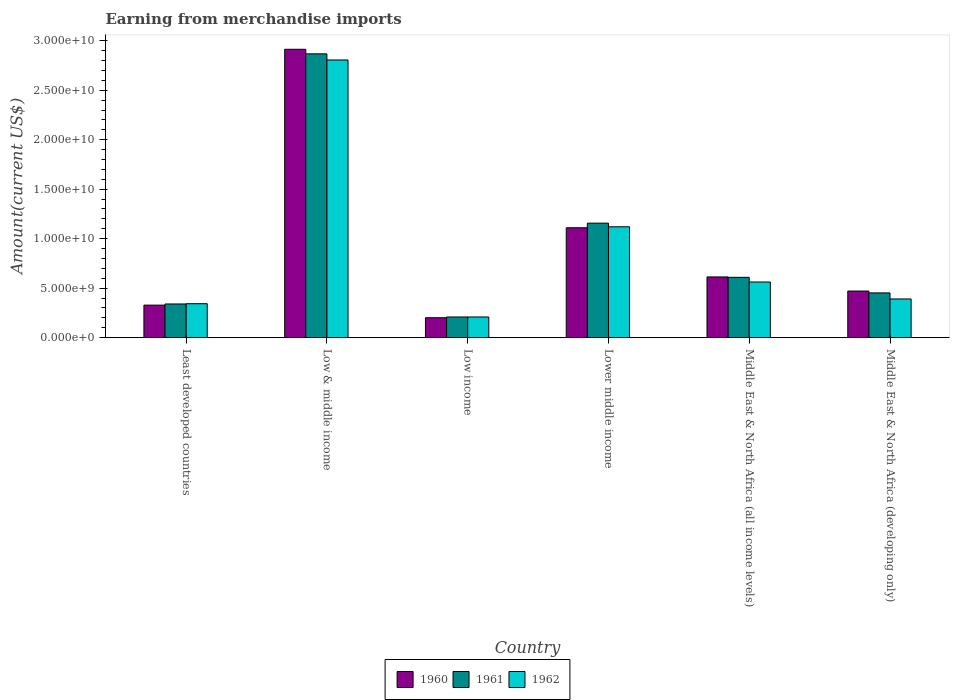How many different coloured bars are there?
Provide a short and direct response. 3. How many groups of bars are there?
Provide a short and direct response. 6. Are the number of bars per tick equal to the number of legend labels?
Provide a short and direct response. Yes. Are the number of bars on each tick of the X-axis equal?
Your answer should be very brief. Yes. How many bars are there on the 5th tick from the left?
Provide a short and direct response. 3. How many bars are there on the 1st tick from the right?
Provide a short and direct response. 3. What is the label of the 2nd group of bars from the left?
Give a very brief answer. Low & middle income. What is the amount earned from merchandise imports in 1961 in Middle East & North Africa (developing only)?
Give a very brief answer. 4.52e+09. Across all countries, what is the maximum amount earned from merchandise imports in 1960?
Your answer should be very brief. 2.91e+1. Across all countries, what is the minimum amount earned from merchandise imports in 1962?
Make the answer very short. 2.09e+09. In which country was the amount earned from merchandise imports in 1962 maximum?
Provide a succinct answer. Low & middle income. What is the total amount earned from merchandise imports in 1962 in the graph?
Provide a short and direct response. 5.43e+1. What is the difference between the amount earned from merchandise imports in 1960 in Low & middle income and that in Lower middle income?
Ensure brevity in your answer.  1.80e+1. What is the difference between the amount earned from merchandise imports in 1961 in Least developed countries and the amount earned from merchandise imports in 1962 in Low & middle income?
Provide a succinct answer. -2.47e+1. What is the average amount earned from merchandise imports in 1960 per country?
Your answer should be compact. 9.40e+09. What is the difference between the amount earned from merchandise imports of/in 1961 and amount earned from merchandise imports of/in 1962 in Low & middle income?
Your response must be concise. 6.18e+08. What is the ratio of the amount earned from merchandise imports in 1960 in Least developed countries to that in Middle East & North Africa (developing only)?
Offer a terse response. 0.7. What is the difference between the highest and the second highest amount earned from merchandise imports in 1961?
Keep it short and to the point. 5.47e+09. What is the difference between the highest and the lowest amount earned from merchandise imports in 1960?
Make the answer very short. 2.71e+1. In how many countries, is the amount earned from merchandise imports in 1961 greater than the average amount earned from merchandise imports in 1961 taken over all countries?
Your answer should be compact. 2. Is the sum of the amount earned from merchandise imports in 1960 in Low income and Middle East & North Africa (developing only) greater than the maximum amount earned from merchandise imports in 1961 across all countries?
Make the answer very short. No. What does the 1st bar from the right in Middle East & North Africa (all income levels) represents?
Keep it short and to the point. 1962. Is it the case that in every country, the sum of the amount earned from merchandise imports in 1961 and amount earned from merchandise imports in 1962 is greater than the amount earned from merchandise imports in 1960?
Offer a terse response. Yes. Are all the bars in the graph horizontal?
Offer a very short reply. No. What is the difference between two consecutive major ticks on the Y-axis?
Your answer should be compact. 5.00e+09. Are the values on the major ticks of Y-axis written in scientific E-notation?
Make the answer very short. Yes. Does the graph contain any zero values?
Offer a very short reply. No. Does the graph contain grids?
Offer a very short reply. No. How are the legend labels stacked?
Your response must be concise. Horizontal. What is the title of the graph?
Offer a terse response. Earning from merchandise imports. What is the label or title of the X-axis?
Make the answer very short. Country. What is the label or title of the Y-axis?
Provide a short and direct response. Amount(current US$). What is the Amount(current US$) of 1960 in Least developed countries?
Make the answer very short. 3.29e+09. What is the Amount(current US$) in 1961 in Least developed countries?
Offer a terse response. 3.40e+09. What is the Amount(current US$) in 1962 in Least developed countries?
Keep it short and to the point. 3.43e+09. What is the Amount(current US$) of 1960 in Low & middle income?
Keep it short and to the point. 2.91e+1. What is the Amount(current US$) in 1961 in Low & middle income?
Ensure brevity in your answer.  2.87e+1. What is the Amount(current US$) of 1962 in Low & middle income?
Ensure brevity in your answer.  2.81e+1. What is the Amount(current US$) of 1960 in Low income?
Offer a terse response. 2.01e+09. What is the Amount(current US$) of 1961 in Low income?
Offer a very short reply. 2.09e+09. What is the Amount(current US$) in 1962 in Low income?
Your response must be concise. 2.09e+09. What is the Amount(current US$) of 1960 in Lower middle income?
Your answer should be very brief. 1.11e+1. What is the Amount(current US$) of 1961 in Lower middle income?
Give a very brief answer. 1.16e+1. What is the Amount(current US$) of 1962 in Lower middle income?
Your answer should be very brief. 1.12e+1. What is the Amount(current US$) of 1960 in Middle East & North Africa (all income levels)?
Your response must be concise. 6.14e+09. What is the Amount(current US$) in 1961 in Middle East & North Africa (all income levels)?
Offer a very short reply. 6.10e+09. What is the Amount(current US$) in 1962 in Middle East & North Africa (all income levels)?
Offer a very short reply. 5.62e+09. What is the Amount(current US$) of 1960 in Middle East & North Africa (developing only)?
Your answer should be compact. 4.71e+09. What is the Amount(current US$) in 1961 in Middle East & North Africa (developing only)?
Provide a short and direct response. 4.52e+09. What is the Amount(current US$) in 1962 in Middle East & North Africa (developing only)?
Ensure brevity in your answer.  3.91e+09. Across all countries, what is the maximum Amount(current US$) of 1960?
Your response must be concise. 2.91e+1. Across all countries, what is the maximum Amount(current US$) of 1961?
Your answer should be compact. 2.87e+1. Across all countries, what is the maximum Amount(current US$) of 1962?
Offer a terse response. 2.81e+1. Across all countries, what is the minimum Amount(current US$) of 1960?
Your answer should be very brief. 2.01e+09. Across all countries, what is the minimum Amount(current US$) in 1961?
Your answer should be very brief. 2.09e+09. Across all countries, what is the minimum Amount(current US$) of 1962?
Your answer should be very brief. 2.09e+09. What is the total Amount(current US$) of 1960 in the graph?
Ensure brevity in your answer.  5.64e+1. What is the total Amount(current US$) of 1961 in the graph?
Provide a succinct answer. 5.64e+1. What is the total Amount(current US$) of 1962 in the graph?
Ensure brevity in your answer.  5.43e+1. What is the difference between the Amount(current US$) in 1960 in Least developed countries and that in Low & middle income?
Provide a short and direct response. -2.58e+1. What is the difference between the Amount(current US$) in 1961 in Least developed countries and that in Low & middle income?
Provide a short and direct response. -2.53e+1. What is the difference between the Amount(current US$) of 1962 in Least developed countries and that in Low & middle income?
Your answer should be compact. -2.46e+1. What is the difference between the Amount(current US$) in 1960 in Least developed countries and that in Low income?
Ensure brevity in your answer.  1.27e+09. What is the difference between the Amount(current US$) in 1961 in Least developed countries and that in Low income?
Keep it short and to the point. 1.31e+09. What is the difference between the Amount(current US$) of 1962 in Least developed countries and that in Low income?
Provide a succinct answer. 1.34e+09. What is the difference between the Amount(current US$) of 1960 in Least developed countries and that in Lower middle income?
Your answer should be very brief. -7.81e+09. What is the difference between the Amount(current US$) of 1961 in Least developed countries and that in Lower middle income?
Your answer should be compact. -8.17e+09. What is the difference between the Amount(current US$) of 1962 in Least developed countries and that in Lower middle income?
Your answer should be very brief. -7.77e+09. What is the difference between the Amount(current US$) in 1960 in Least developed countries and that in Middle East & North Africa (all income levels)?
Keep it short and to the point. -2.85e+09. What is the difference between the Amount(current US$) in 1961 in Least developed countries and that in Middle East & North Africa (all income levels)?
Offer a terse response. -2.69e+09. What is the difference between the Amount(current US$) in 1962 in Least developed countries and that in Middle East & North Africa (all income levels)?
Your answer should be compact. -2.19e+09. What is the difference between the Amount(current US$) of 1960 in Least developed countries and that in Middle East & North Africa (developing only)?
Give a very brief answer. -1.42e+09. What is the difference between the Amount(current US$) of 1961 in Least developed countries and that in Middle East & North Africa (developing only)?
Give a very brief answer. -1.12e+09. What is the difference between the Amount(current US$) of 1962 in Least developed countries and that in Middle East & North Africa (developing only)?
Offer a terse response. -4.79e+08. What is the difference between the Amount(current US$) in 1960 in Low & middle income and that in Low income?
Keep it short and to the point. 2.71e+1. What is the difference between the Amount(current US$) of 1961 in Low & middle income and that in Low income?
Provide a short and direct response. 2.66e+1. What is the difference between the Amount(current US$) in 1962 in Low & middle income and that in Low income?
Provide a short and direct response. 2.60e+1. What is the difference between the Amount(current US$) in 1960 in Low & middle income and that in Lower middle income?
Your answer should be compact. 1.80e+1. What is the difference between the Amount(current US$) in 1961 in Low & middle income and that in Lower middle income?
Offer a very short reply. 1.71e+1. What is the difference between the Amount(current US$) of 1962 in Low & middle income and that in Lower middle income?
Offer a very short reply. 1.69e+1. What is the difference between the Amount(current US$) of 1960 in Low & middle income and that in Middle East & North Africa (all income levels)?
Provide a short and direct response. 2.30e+1. What is the difference between the Amount(current US$) of 1961 in Low & middle income and that in Middle East & North Africa (all income levels)?
Provide a succinct answer. 2.26e+1. What is the difference between the Amount(current US$) of 1962 in Low & middle income and that in Middle East & North Africa (all income levels)?
Provide a succinct answer. 2.24e+1. What is the difference between the Amount(current US$) in 1960 in Low & middle income and that in Middle East & North Africa (developing only)?
Your response must be concise. 2.44e+1. What is the difference between the Amount(current US$) in 1961 in Low & middle income and that in Middle East & North Africa (developing only)?
Offer a terse response. 2.42e+1. What is the difference between the Amount(current US$) of 1962 in Low & middle income and that in Middle East & North Africa (developing only)?
Your answer should be very brief. 2.41e+1. What is the difference between the Amount(current US$) of 1960 in Low income and that in Lower middle income?
Your response must be concise. -9.09e+09. What is the difference between the Amount(current US$) in 1961 in Low income and that in Lower middle income?
Keep it short and to the point. -9.48e+09. What is the difference between the Amount(current US$) in 1962 in Low income and that in Lower middle income?
Provide a succinct answer. -9.11e+09. What is the difference between the Amount(current US$) of 1960 in Low income and that in Middle East & North Africa (all income levels)?
Keep it short and to the point. -4.12e+09. What is the difference between the Amount(current US$) in 1961 in Low income and that in Middle East & North Africa (all income levels)?
Offer a terse response. -4.01e+09. What is the difference between the Amount(current US$) of 1962 in Low income and that in Middle East & North Africa (all income levels)?
Make the answer very short. -3.53e+09. What is the difference between the Amount(current US$) of 1960 in Low income and that in Middle East & North Africa (developing only)?
Your response must be concise. -2.70e+09. What is the difference between the Amount(current US$) in 1961 in Low income and that in Middle East & North Africa (developing only)?
Offer a very short reply. -2.43e+09. What is the difference between the Amount(current US$) in 1962 in Low income and that in Middle East & North Africa (developing only)?
Offer a very short reply. -1.82e+09. What is the difference between the Amount(current US$) in 1960 in Lower middle income and that in Middle East & North Africa (all income levels)?
Your answer should be very brief. 4.97e+09. What is the difference between the Amount(current US$) of 1961 in Lower middle income and that in Middle East & North Africa (all income levels)?
Ensure brevity in your answer.  5.47e+09. What is the difference between the Amount(current US$) of 1962 in Lower middle income and that in Middle East & North Africa (all income levels)?
Provide a succinct answer. 5.58e+09. What is the difference between the Amount(current US$) in 1960 in Lower middle income and that in Middle East & North Africa (developing only)?
Your answer should be compact. 6.39e+09. What is the difference between the Amount(current US$) in 1961 in Lower middle income and that in Middle East & North Africa (developing only)?
Offer a very short reply. 7.05e+09. What is the difference between the Amount(current US$) in 1962 in Lower middle income and that in Middle East & North Africa (developing only)?
Your answer should be very brief. 7.29e+09. What is the difference between the Amount(current US$) of 1960 in Middle East & North Africa (all income levels) and that in Middle East & North Africa (developing only)?
Keep it short and to the point. 1.43e+09. What is the difference between the Amount(current US$) in 1961 in Middle East & North Africa (all income levels) and that in Middle East & North Africa (developing only)?
Your response must be concise. 1.57e+09. What is the difference between the Amount(current US$) in 1962 in Middle East & North Africa (all income levels) and that in Middle East & North Africa (developing only)?
Keep it short and to the point. 1.71e+09. What is the difference between the Amount(current US$) of 1960 in Least developed countries and the Amount(current US$) of 1961 in Low & middle income?
Your answer should be very brief. -2.54e+1. What is the difference between the Amount(current US$) of 1960 in Least developed countries and the Amount(current US$) of 1962 in Low & middle income?
Your response must be concise. -2.48e+1. What is the difference between the Amount(current US$) in 1961 in Least developed countries and the Amount(current US$) in 1962 in Low & middle income?
Offer a very short reply. -2.47e+1. What is the difference between the Amount(current US$) in 1960 in Least developed countries and the Amount(current US$) in 1961 in Low income?
Keep it short and to the point. 1.20e+09. What is the difference between the Amount(current US$) in 1960 in Least developed countries and the Amount(current US$) in 1962 in Low income?
Give a very brief answer. 1.20e+09. What is the difference between the Amount(current US$) of 1961 in Least developed countries and the Amount(current US$) of 1962 in Low income?
Offer a very short reply. 1.31e+09. What is the difference between the Amount(current US$) in 1960 in Least developed countries and the Amount(current US$) in 1961 in Lower middle income?
Offer a terse response. -8.28e+09. What is the difference between the Amount(current US$) of 1960 in Least developed countries and the Amount(current US$) of 1962 in Lower middle income?
Ensure brevity in your answer.  -7.92e+09. What is the difference between the Amount(current US$) in 1961 in Least developed countries and the Amount(current US$) in 1962 in Lower middle income?
Your answer should be very brief. -7.80e+09. What is the difference between the Amount(current US$) in 1960 in Least developed countries and the Amount(current US$) in 1961 in Middle East & North Africa (all income levels)?
Your answer should be very brief. -2.81e+09. What is the difference between the Amount(current US$) in 1960 in Least developed countries and the Amount(current US$) in 1962 in Middle East & North Africa (all income levels)?
Make the answer very short. -2.34e+09. What is the difference between the Amount(current US$) of 1961 in Least developed countries and the Amount(current US$) of 1962 in Middle East & North Africa (all income levels)?
Your response must be concise. -2.22e+09. What is the difference between the Amount(current US$) of 1960 in Least developed countries and the Amount(current US$) of 1961 in Middle East & North Africa (developing only)?
Offer a very short reply. -1.23e+09. What is the difference between the Amount(current US$) in 1960 in Least developed countries and the Amount(current US$) in 1962 in Middle East & North Africa (developing only)?
Keep it short and to the point. -6.23e+08. What is the difference between the Amount(current US$) in 1961 in Least developed countries and the Amount(current US$) in 1962 in Middle East & North Africa (developing only)?
Offer a very short reply. -5.06e+08. What is the difference between the Amount(current US$) of 1960 in Low & middle income and the Amount(current US$) of 1961 in Low income?
Make the answer very short. 2.70e+1. What is the difference between the Amount(current US$) of 1960 in Low & middle income and the Amount(current US$) of 1962 in Low income?
Make the answer very short. 2.70e+1. What is the difference between the Amount(current US$) of 1961 in Low & middle income and the Amount(current US$) of 1962 in Low income?
Keep it short and to the point. 2.66e+1. What is the difference between the Amount(current US$) in 1960 in Low & middle income and the Amount(current US$) in 1961 in Lower middle income?
Make the answer very short. 1.76e+1. What is the difference between the Amount(current US$) of 1960 in Low & middle income and the Amount(current US$) of 1962 in Lower middle income?
Give a very brief answer. 1.79e+1. What is the difference between the Amount(current US$) of 1961 in Low & middle income and the Amount(current US$) of 1962 in Lower middle income?
Provide a short and direct response. 1.75e+1. What is the difference between the Amount(current US$) in 1960 in Low & middle income and the Amount(current US$) in 1961 in Middle East & North Africa (all income levels)?
Your answer should be very brief. 2.30e+1. What is the difference between the Amount(current US$) in 1960 in Low & middle income and the Amount(current US$) in 1962 in Middle East & North Africa (all income levels)?
Offer a very short reply. 2.35e+1. What is the difference between the Amount(current US$) in 1961 in Low & middle income and the Amount(current US$) in 1962 in Middle East & North Africa (all income levels)?
Your answer should be very brief. 2.31e+1. What is the difference between the Amount(current US$) in 1960 in Low & middle income and the Amount(current US$) in 1961 in Middle East & North Africa (developing only)?
Ensure brevity in your answer.  2.46e+1. What is the difference between the Amount(current US$) in 1960 in Low & middle income and the Amount(current US$) in 1962 in Middle East & North Africa (developing only)?
Offer a very short reply. 2.52e+1. What is the difference between the Amount(current US$) of 1961 in Low & middle income and the Amount(current US$) of 1962 in Middle East & North Africa (developing only)?
Offer a very short reply. 2.48e+1. What is the difference between the Amount(current US$) of 1960 in Low income and the Amount(current US$) of 1961 in Lower middle income?
Keep it short and to the point. -9.56e+09. What is the difference between the Amount(current US$) of 1960 in Low income and the Amount(current US$) of 1962 in Lower middle income?
Give a very brief answer. -9.19e+09. What is the difference between the Amount(current US$) of 1961 in Low income and the Amount(current US$) of 1962 in Lower middle income?
Offer a terse response. -9.11e+09. What is the difference between the Amount(current US$) in 1960 in Low income and the Amount(current US$) in 1961 in Middle East & North Africa (all income levels)?
Ensure brevity in your answer.  -4.08e+09. What is the difference between the Amount(current US$) in 1960 in Low income and the Amount(current US$) in 1962 in Middle East & North Africa (all income levels)?
Your answer should be very brief. -3.61e+09. What is the difference between the Amount(current US$) of 1961 in Low income and the Amount(current US$) of 1962 in Middle East & North Africa (all income levels)?
Ensure brevity in your answer.  -3.53e+09. What is the difference between the Amount(current US$) in 1960 in Low income and the Amount(current US$) in 1961 in Middle East & North Africa (developing only)?
Ensure brevity in your answer.  -2.51e+09. What is the difference between the Amount(current US$) of 1960 in Low income and the Amount(current US$) of 1962 in Middle East & North Africa (developing only)?
Give a very brief answer. -1.90e+09. What is the difference between the Amount(current US$) of 1961 in Low income and the Amount(current US$) of 1962 in Middle East & North Africa (developing only)?
Provide a short and direct response. -1.82e+09. What is the difference between the Amount(current US$) in 1960 in Lower middle income and the Amount(current US$) in 1961 in Middle East & North Africa (all income levels)?
Offer a terse response. 5.01e+09. What is the difference between the Amount(current US$) of 1960 in Lower middle income and the Amount(current US$) of 1962 in Middle East & North Africa (all income levels)?
Ensure brevity in your answer.  5.48e+09. What is the difference between the Amount(current US$) of 1961 in Lower middle income and the Amount(current US$) of 1962 in Middle East & North Africa (all income levels)?
Offer a terse response. 5.95e+09. What is the difference between the Amount(current US$) of 1960 in Lower middle income and the Amount(current US$) of 1961 in Middle East & North Africa (developing only)?
Offer a terse response. 6.58e+09. What is the difference between the Amount(current US$) in 1960 in Lower middle income and the Amount(current US$) in 1962 in Middle East & North Africa (developing only)?
Provide a short and direct response. 7.19e+09. What is the difference between the Amount(current US$) of 1961 in Lower middle income and the Amount(current US$) of 1962 in Middle East & North Africa (developing only)?
Provide a succinct answer. 7.66e+09. What is the difference between the Amount(current US$) in 1960 in Middle East & North Africa (all income levels) and the Amount(current US$) in 1961 in Middle East & North Africa (developing only)?
Offer a terse response. 1.61e+09. What is the difference between the Amount(current US$) in 1960 in Middle East & North Africa (all income levels) and the Amount(current US$) in 1962 in Middle East & North Africa (developing only)?
Offer a terse response. 2.23e+09. What is the difference between the Amount(current US$) of 1961 in Middle East & North Africa (all income levels) and the Amount(current US$) of 1962 in Middle East & North Africa (developing only)?
Provide a succinct answer. 2.19e+09. What is the average Amount(current US$) of 1960 per country?
Keep it short and to the point. 9.40e+09. What is the average Amount(current US$) in 1961 per country?
Keep it short and to the point. 9.39e+09. What is the average Amount(current US$) of 1962 per country?
Keep it short and to the point. 9.05e+09. What is the difference between the Amount(current US$) of 1960 and Amount(current US$) of 1961 in Least developed countries?
Provide a succinct answer. -1.16e+08. What is the difference between the Amount(current US$) in 1960 and Amount(current US$) in 1962 in Least developed countries?
Offer a terse response. -1.44e+08. What is the difference between the Amount(current US$) in 1961 and Amount(current US$) in 1962 in Least developed countries?
Give a very brief answer. -2.73e+07. What is the difference between the Amount(current US$) of 1960 and Amount(current US$) of 1961 in Low & middle income?
Provide a succinct answer. 4.61e+08. What is the difference between the Amount(current US$) of 1960 and Amount(current US$) of 1962 in Low & middle income?
Give a very brief answer. 1.08e+09. What is the difference between the Amount(current US$) of 1961 and Amount(current US$) of 1962 in Low & middle income?
Make the answer very short. 6.18e+08. What is the difference between the Amount(current US$) in 1960 and Amount(current US$) in 1961 in Low income?
Your response must be concise. -7.57e+07. What is the difference between the Amount(current US$) in 1960 and Amount(current US$) in 1962 in Low income?
Give a very brief answer. -7.57e+07. What is the difference between the Amount(current US$) of 1961 and Amount(current US$) of 1962 in Low income?
Your response must be concise. -5.06e+04. What is the difference between the Amount(current US$) in 1960 and Amount(current US$) in 1961 in Lower middle income?
Ensure brevity in your answer.  -4.68e+08. What is the difference between the Amount(current US$) in 1960 and Amount(current US$) in 1962 in Lower middle income?
Ensure brevity in your answer.  -1.01e+08. What is the difference between the Amount(current US$) in 1961 and Amount(current US$) in 1962 in Lower middle income?
Provide a succinct answer. 3.67e+08. What is the difference between the Amount(current US$) in 1960 and Amount(current US$) in 1961 in Middle East & North Africa (all income levels)?
Your answer should be very brief. 4.07e+07. What is the difference between the Amount(current US$) in 1960 and Amount(current US$) in 1962 in Middle East & North Africa (all income levels)?
Give a very brief answer. 5.14e+08. What is the difference between the Amount(current US$) of 1961 and Amount(current US$) of 1962 in Middle East & North Africa (all income levels)?
Your response must be concise. 4.73e+08. What is the difference between the Amount(current US$) in 1960 and Amount(current US$) in 1961 in Middle East & North Africa (developing only)?
Offer a terse response. 1.90e+08. What is the difference between the Amount(current US$) in 1960 and Amount(current US$) in 1962 in Middle East & North Africa (developing only)?
Provide a succinct answer. 8.01e+08. What is the difference between the Amount(current US$) in 1961 and Amount(current US$) in 1962 in Middle East & North Africa (developing only)?
Your answer should be compact. 6.11e+08. What is the ratio of the Amount(current US$) of 1960 in Least developed countries to that in Low & middle income?
Keep it short and to the point. 0.11. What is the ratio of the Amount(current US$) in 1961 in Least developed countries to that in Low & middle income?
Provide a short and direct response. 0.12. What is the ratio of the Amount(current US$) of 1962 in Least developed countries to that in Low & middle income?
Provide a short and direct response. 0.12. What is the ratio of the Amount(current US$) in 1960 in Least developed countries to that in Low income?
Your answer should be very brief. 1.63. What is the ratio of the Amount(current US$) in 1961 in Least developed countries to that in Low income?
Provide a short and direct response. 1.63. What is the ratio of the Amount(current US$) in 1962 in Least developed countries to that in Low income?
Keep it short and to the point. 1.64. What is the ratio of the Amount(current US$) of 1960 in Least developed countries to that in Lower middle income?
Your answer should be compact. 0.3. What is the ratio of the Amount(current US$) in 1961 in Least developed countries to that in Lower middle income?
Provide a short and direct response. 0.29. What is the ratio of the Amount(current US$) of 1962 in Least developed countries to that in Lower middle income?
Provide a short and direct response. 0.31. What is the ratio of the Amount(current US$) in 1960 in Least developed countries to that in Middle East & North Africa (all income levels)?
Offer a very short reply. 0.54. What is the ratio of the Amount(current US$) of 1961 in Least developed countries to that in Middle East & North Africa (all income levels)?
Offer a terse response. 0.56. What is the ratio of the Amount(current US$) in 1962 in Least developed countries to that in Middle East & North Africa (all income levels)?
Offer a very short reply. 0.61. What is the ratio of the Amount(current US$) in 1960 in Least developed countries to that in Middle East & North Africa (developing only)?
Provide a succinct answer. 0.7. What is the ratio of the Amount(current US$) of 1961 in Least developed countries to that in Middle East & North Africa (developing only)?
Make the answer very short. 0.75. What is the ratio of the Amount(current US$) in 1962 in Least developed countries to that in Middle East & North Africa (developing only)?
Give a very brief answer. 0.88. What is the ratio of the Amount(current US$) in 1960 in Low & middle income to that in Low income?
Offer a very short reply. 14.47. What is the ratio of the Amount(current US$) in 1961 in Low & middle income to that in Low income?
Your answer should be very brief. 13.72. What is the ratio of the Amount(current US$) of 1962 in Low & middle income to that in Low income?
Make the answer very short. 13.42. What is the ratio of the Amount(current US$) of 1960 in Low & middle income to that in Lower middle income?
Keep it short and to the point. 2.62. What is the ratio of the Amount(current US$) of 1961 in Low & middle income to that in Lower middle income?
Make the answer very short. 2.48. What is the ratio of the Amount(current US$) in 1962 in Low & middle income to that in Lower middle income?
Keep it short and to the point. 2.5. What is the ratio of the Amount(current US$) of 1960 in Low & middle income to that in Middle East & North Africa (all income levels)?
Provide a succinct answer. 4.75. What is the ratio of the Amount(current US$) of 1961 in Low & middle income to that in Middle East & North Africa (all income levels)?
Offer a terse response. 4.7. What is the ratio of the Amount(current US$) of 1962 in Low & middle income to that in Middle East & North Africa (all income levels)?
Give a very brief answer. 4.99. What is the ratio of the Amount(current US$) of 1960 in Low & middle income to that in Middle East & North Africa (developing only)?
Your answer should be very brief. 6.18. What is the ratio of the Amount(current US$) in 1961 in Low & middle income to that in Middle East & North Africa (developing only)?
Offer a very short reply. 6.34. What is the ratio of the Amount(current US$) in 1962 in Low & middle income to that in Middle East & North Africa (developing only)?
Offer a terse response. 7.18. What is the ratio of the Amount(current US$) of 1960 in Low income to that in Lower middle income?
Make the answer very short. 0.18. What is the ratio of the Amount(current US$) of 1961 in Low income to that in Lower middle income?
Your answer should be very brief. 0.18. What is the ratio of the Amount(current US$) in 1962 in Low income to that in Lower middle income?
Give a very brief answer. 0.19. What is the ratio of the Amount(current US$) of 1960 in Low income to that in Middle East & North Africa (all income levels)?
Offer a very short reply. 0.33. What is the ratio of the Amount(current US$) in 1961 in Low income to that in Middle East & North Africa (all income levels)?
Keep it short and to the point. 0.34. What is the ratio of the Amount(current US$) of 1962 in Low income to that in Middle East & North Africa (all income levels)?
Make the answer very short. 0.37. What is the ratio of the Amount(current US$) of 1960 in Low income to that in Middle East & North Africa (developing only)?
Offer a terse response. 0.43. What is the ratio of the Amount(current US$) of 1961 in Low income to that in Middle East & North Africa (developing only)?
Provide a succinct answer. 0.46. What is the ratio of the Amount(current US$) of 1962 in Low income to that in Middle East & North Africa (developing only)?
Provide a succinct answer. 0.53. What is the ratio of the Amount(current US$) of 1960 in Lower middle income to that in Middle East & North Africa (all income levels)?
Give a very brief answer. 1.81. What is the ratio of the Amount(current US$) in 1961 in Lower middle income to that in Middle East & North Africa (all income levels)?
Offer a terse response. 1.9. What is the ratio of the Amount(current US$) in 1962 in Lower middle income to that in Middle East & North Africa (all income levels)?
Provide a short and direct response. 1.99. What is the ratio of the Amount(current US$) in 1960 in Lower middle income to that in Middle East & North Africa (developing only)?
Make the answer very short. 2.36. What is the ratio of the Amount(current US$) of 1961 in Lower middle income to that in Middle East & North Africa (developing only)?
Offer a very short reply. 2.56. What is the ratio of the Amount(current US$) in 1962 in Lower middle income to that in Middle East & North Africa (developing only)?
Provide a succinct answer. 2.87. What is the ratio of the Amount(current US$) in 1960 in Middle East & North Africa (all income levels) to that in Middle East & North Africa (developing only)?
Your answer should be very brief. 1.3. What is the ratio of the Amount(current US$) in 1961 in Middle East & North Africa (all income levels) to that in Middle East & North Africa (developing only)?
Offer a terse response. 1.35. What is the ratio of the Amount(current US$) of 1962 in Middle East & North Africa (all income levels) to that in Middle East & North Africa (developing only)?
Offer a very short reply. 1.44. What is the difference between the highest and the second highest Amount(current US$) of 1960?
Provide a succinct answer. 1.80e+1. What is the difference between the highest and the second highest Amount(current US$) in 1961?
Provide a short and direct response. 1.71e+1. What is the difference between the highest and the second highest Amount(current US$) of 1962?
Offer a terse response. 1.69e+1. What is the difference between the highest and the lowest Amount(current US$) in 1960?
Your answer should be very brief. 2.71e+1. What is the difference between the highest and the lowest Amount(current US$) in 1961?
Your response must be concise. 2.66e+1. What is the difference between the highest and the lowest Amount(current US$) in 1962?
Give a very brief answer. 2.60e+1. 